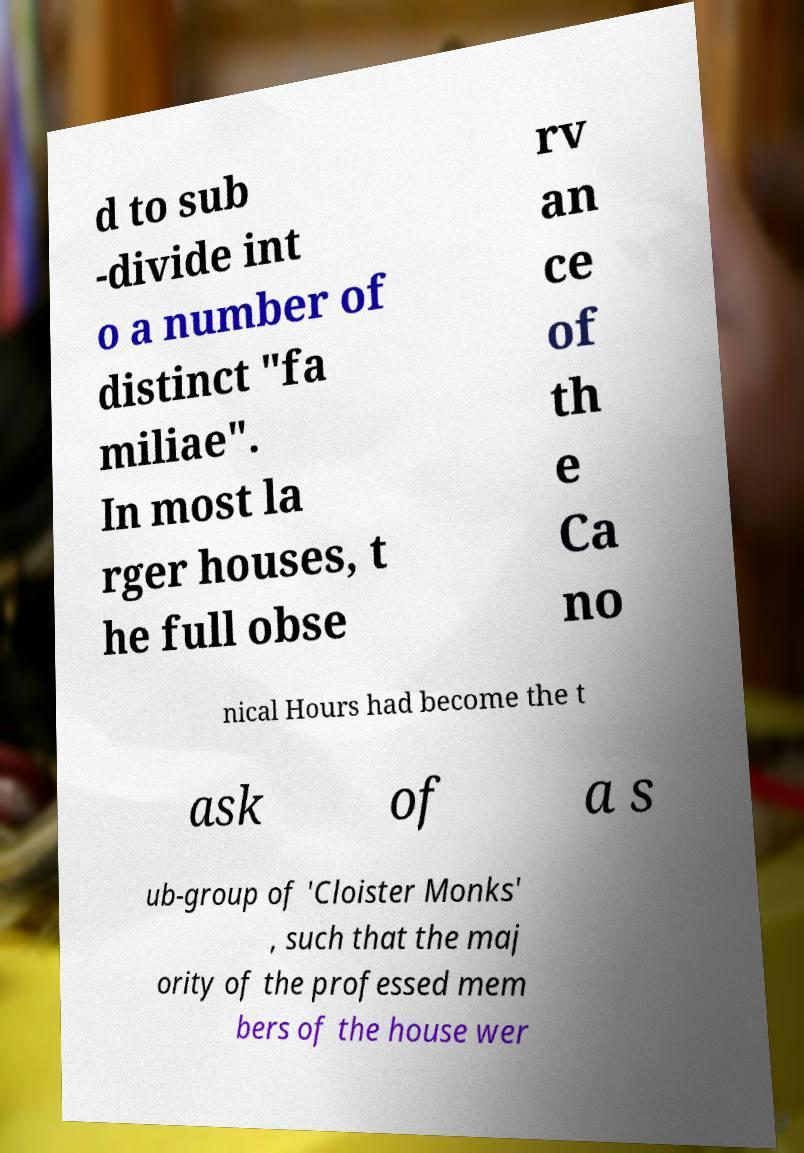I need the written content from this picture converted into text. Can you do that? d to sub -divide int o a number of distinct "fa miliae". In most la rger houses, t he full obse rv an ce of th e Ca no nical Hours had become the t ask of a s ub-group of 'Cloister Monks' , such that the maj ority of the professed mem bers of the house wer 